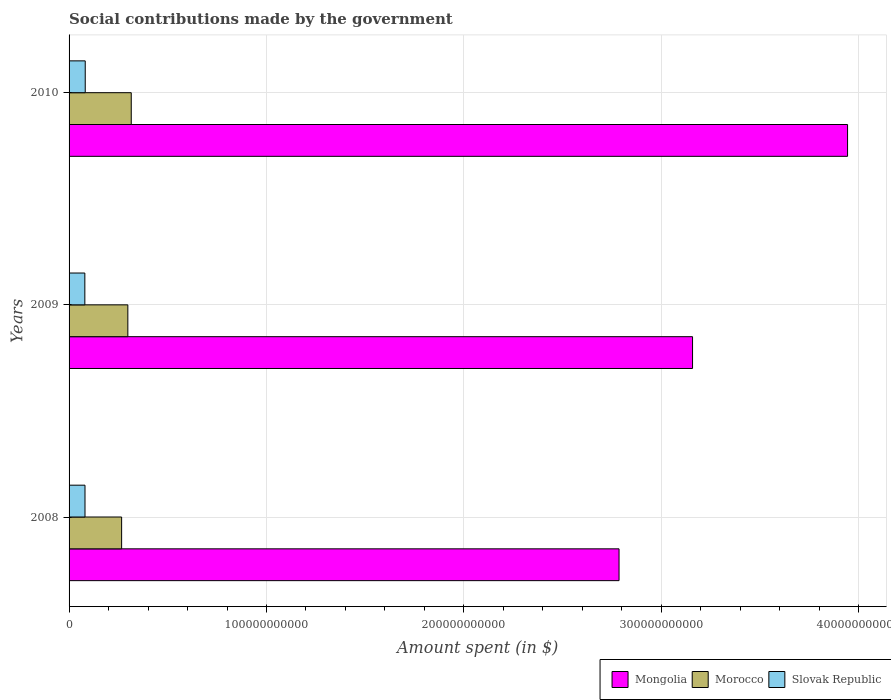How many groups of bars are there?
Provide a short and direct response. 3. How many bars are there on the 2nd tick from the top?
Provide a short and direct response. 3. What is the amount spent on social contributions in Morocco in 2010?
Provide a succinct answer. 3.15e+1. Across all years, what is the maximum amount spent on social contributions in Slovak Republic?
Your response must be concise. 8.18e+09. Across all years, what is the minimum amount spent on social contributions in Slovak Republic?
Offer a terse response. 7.99e+09. What is the total amount spent on social contributions in Mongolia in the graph?
Offer a very short reply. 9.89e+11. What is the difference between the amount spent on social contributions in Mongolia in 2008 and that in 2009?
Ensure brevity in your answer.  -3.72e+1. What is the difference between the amount spent on social contributions in Morocco in 2010 and the amount spent on social contributions in Slovak Republic in 2009?
Provide a succinct answer. 2.35e+1. What is the average amount spent on social contributions in Mongolia per year?
Offer a very short reply. 3.30e+11. In the year 2010, what is the difference between the amount spent on social contributions in Slovak Republic and amount spent on social contributions in Mongolia?
Your answer should be very brief. -3.86e+11. What is the ratio of the amount spent on social contributions in Mongolia in 2008 to that in 2009?
Offer a terse response. 0.88. Is the difference between the amount spent on social contributions in Slovak Republic in 2008 and 2009 greater than the difference between the amount spent on social contributions in Mongolia in 2008 and 2009?
Ensure brevity in your answer.  Yes. What is the difference between the highest and the second highest amount spent on social contributions in Morocco?
Offer a very short reply. 1.73e+09. What is the difference between the highest and the lowest amount spent on social contributions in Mongolia?
Your answer should be compact. 1.16e+11. In how many years, is the amount spent on social contributions in Slovak Republic greater than the average amount spent on social contributions in Slovak Republic taken over all years?
Provide a succinct answer. 1. Is the sum of the amount spent on social contributions in Morocco in 2008 and 2009 greater than the maximum amount spent on social contributions in Mongolia across all years?
Your answer should be compact. No. What does the 1st bar from the top in 2010 represents?
Provide a short and direct response. Slovak Republic. What does the 1st bar from the bottom in 2009 represents?
Your response must be concise. Mongolia. Is it the case that in every year, the sum of the amount spent on social contributions in Morocco and amount spent on social contributions in Slovak Republic is greater than the amount spent on social contributions in Mongolia?
Make the answer very short. No. How many years are there in the graph?
Provide a succinct answer. 3. What is the difference between two consecutive major ticks on the X-axis?
Give a very brief answer. 1.00e+11. Are the values on the major ticks of X-axis written in scientific E-notation?
Give a very brief answer. No. Does the graph contain grids?
Offer a very short reply. Yes. Where does the legend appear in the graph?
Provide a short and direct response. Bottom right. How many legend labels are there?
Keep it short and to the point. 3. What is the title of the graph?
Offer a very short reply. Social contributions made by the government. What is the label or title of the X-axis?
Keep it short and to the point. Amount spent (in $). What is the Amount spent (in $) in Mongolia in 2008?
Make the answer very short. 2.79e+11. What is the Amount spent (in $) in Morocco in 2008?
Keep it short and to the point. 2.66e+1. What is the Amount spent (in $) of Slovak Republic in 2008?
Offer a very short reply. 8.07e+09. What is the Amount spent (in $) of Mongolia in 2009?
Your answer should be compact. 3.16e+11. What is the Amount spent (in $) of Morocco in 2009?
Your answer should be compact. 2.98e+1. What is the Amount spent (in $) in Slovak Republic in 2009?
Ensure brevity in your answer.  7.99e+09. What is the Amount spent (in $) in Mongolia in 2010?
Your answer should be very brief. 3.94e+11. What is the Amount spent (in $) of Morocco in 2010?
Give a very brief answer. 3.15e+1. What is the Amount spent (in $) in Slovak Republic in 2010?
Provide a succinct answer. 8.18e+09. Across all years, what is the maximum Amount spent (in $) of Mongolia?
Your response must be concise. 3.94e+11. Across all years, what is the maximum Amount spent (in $) in Morocco?
Your response must be concise. 3.15e+1. Across all years, what is the maximum Amount spent (in $) in Slovak Republic?
Give a very brief answer. 8.18e+09. Across all years, what is the minimum Amount spent (in $) of Mongolia?
Offer a very short reply. 2.79e+11. Across all years, what is the minimum Amount spent (in $) in Morocco?
Provide a short and direct response. 2.66e+1. Across all years, what is the minimum Amount spent (in $) in Slovak Republic?
Provide a short and direct response. 7.99e+09. What is the total Amount spent (in $) of Mongolia in the graph?
Keep it short and to the point. 9.89e+11. What is the total Amount spent (in $) of Morocco in the graph?
Provide a short and direct response. 8.79e+1. What is the total Amount spent (in $) of Slovak Republic in the graph?
Offer a very short reply. 2.42e+1. What is the difference between the Amount spent (in $) in Mongolia in 2008 and that in 2009?
Ensure brevity in your answer.  -3.72e+1. What is the difference between the Amount spent (in $) of Morocco in 2008 and that in 2009?
Give a very brief answer. -3.15e+09. What is the difference between the Amount spent (in $) in Slovak Republic in 2008 and that in 2009?
Ensure brevity in your answer.  7.78e+07. What is the difference between the Amount spent (in $) of Mongolia in 2008 and that in 2010?
Ensure brevity in your answer.  -1.16e+11. What is the difference between the Amount spent (in $) in Morocco in 2008 and that in 2010?
Keep it short and to the point. -4.88e+09. What is the difference between the Amount spent (in $) in Slovak Republic in 2008 and that in 2010?
Ensure brevity in your answer.  -1.13e+08. What is the difference between the Amount spent (in $) of Mongolia in 2009 and that in 2010?
Offer a terse response. -7.85e+1. What is the difference between the Amount spent (in $) in Morocco in 2009 and that in 2010?
Your answer should be very brief. -1.73e+09. What is the difference between the Amount spent (in $) in Slovak Republic in 2009 and that in 2010?
Ensure brevity in your answer.  -1.91e+08. What is the difference between the Amount spent (in $) of Mongolia in 2008 and the Amount spent (in $) of Morocco in 2009?
Offer a very short reply. 2.49e+11. What is the difference between the Amount spent (in $) in Mongolia in 2008 and the Amount spent (in $) in Slovak Republic in 2009?
Your answer should be very brief. 2.71e+11. What is the difference between the Amount spent (in $) in Morocco in 2008 and the Amount spent (in $) in Slovak Republic in 2009?
Your answer should be very brief. 1.86e+1. What is the difference between the Amount spent (in $) in Mongolia in 2008 and the Amount spent (in $) in Morocco in 2010?
Give a very brief answer. 2.47e+11. What is the difference between the Amount spent (in $) of Mongolia in 2008 and the Amount spent (in $) of Slovak Republic in 2010?
Give a very brief answer. 2.70e+11. What is the difference between the Amount spent (in $) in Morocco in 2008 and the Amount spent (in $) in Slovak Republic in 2010?
Your response must be concise. 1.84e+1. What is the difference between the Amount spent (in $) of Mongolia in 2009 and the Amount spent (in $) of Morocco in 2010?
Offer a terse response. 2.84e+11. What is the difference between the Amount spent (in $) in Mongolia in 2009 and the Amount spent (in $) in Slovak Republic in 2010?
Offer a very short reply. 3.08e+11. What is the difference between the Amount spent (in $) of Morocco in 2009 and the Amount spent (in $) of Slovak Republic in 2010?
Your answer should be compact. 2.16e+1. What is the average Amount spent (in $) of Mongolia per year?
Give a very brief answer. 3.30e+11. What is the average Amount spent (in $) of Morocco per year?
Offer a very short reply. 2.93e+1. What is the average Amount spent (in $) in Slovak Republic per year?
Give a very brief answer. 8.08e+09. In the year 2008, what is the difference between the Amount spent (in $) of Mongolia and Amount spent (in $) of Morocco?
Provide a short and direct response. 2.52e+11. In the year 2008, what is the difference between the Amount spent (in $) of Mongolia and Amount spent (in $) of Slovak Republic?
Give a very brief answer. 2.70e+11. In the year 2008, what is the difference between the Amount spent (in $) of Morocco and Amount spent (in $) of Slovak Republic?
Offer a terse response. 1.85e+1. In the year 2009, what is the difference between the Amount spent (in $) of Mongolia and Amount spent (in $) of Morocco?
Keep it short and to the point. 2.86e+11. In the year 2009, what is the difference between the Amount spent (in $) in Mongolia and Amount spent (in $) in Slovak Republic?
Your response must be concise. 3.08e+11. In the year 2009, what is the difference between the Amount spent (in $) in Morocco and Amount spent (in $) in Slovak Republic?
Give a very brief answer. 2.18e+1. In the year 2010, what is the difference between the Amount spent (in $) of Mongolia and Amount spent (in $) of Morocco?
Ensure brevity in your answer.  3.63e+11. In the year 2010, what is the difference between the Amount spent (in $) of Mongolia and Amount spent (in $) of Slovak Republic?
Provide a succinct answer. 3.86e+11. In the year 2010, what is the difference between the Amount spent (in $) of Morocco and Amount spent (in $) of Slovak Republic?
Give a very brief answer. 2.33e+1. What is the ratio of the Amount spent (in $) of Mongolia in 2008 to that in 2009?
Offer a terse response. 0.88. What is the ratio of the Amount spent (in $) in Morocco in 2008 to that in 2009?
Your answer should be compact. 0.89. What is the ratio of the Amount spent (in $) of Slovak Republic in 2008 to that in 2009?
Provide a short and direct response. 1.01. What is the ratio of the Amount spent (in $) in Mongolia in 2008 to that in 2010?
Offer a very short reply. 0.71. What is the ratio of the Amount spent (in $) in Morocco in 2008 to that in 2010?
Give a very brief answer. 0.85. What is the ratio of the Amount spent (in $) of Slovak Republic in 2008 to that in 2010?
Offer a very short reply. 0.99. What is the ratio of the Amount spent (in $) of Mongolia in 2009 to that in 2010?
Offer a terse response. 0.8. What is the ratio of the Amount spent (in $) of Morocco in 2009 to that in 2010?
Provide a short and direct response. 0.95. What is the ratio of the Amount spent (in $) of Slovak Republic in 2009 to that in 2010?
Give a very brief answer. 0.98. What is the difference between the highest and the second highest Amount spent (in $) of Mongolia?
Ensure brevity in your answer.  7.85e+1. What is the difference between the highest and the second highest Amount spent (in $) in Morocco?
Provide a succinct answer. 1.73e+09. What is the difference between the highest and the second highest Amount spent (in $) of Slovak Republic?
Give a very brief answer. 1.13e+08. What is the difference between the highest and the lowest Amount spent (in $) in Mongolia?
Ensure brevity in your answer.  1.16e+11. What is the difference between the highest and the lowest Amount spent (in $) in Morocco?
Keep it short and to the point. 4.88e+09. What is the difference between the highest and the lowest Amount spent (in $) of Slovak Republic?
Offer a terse response. 1.91e+08. 